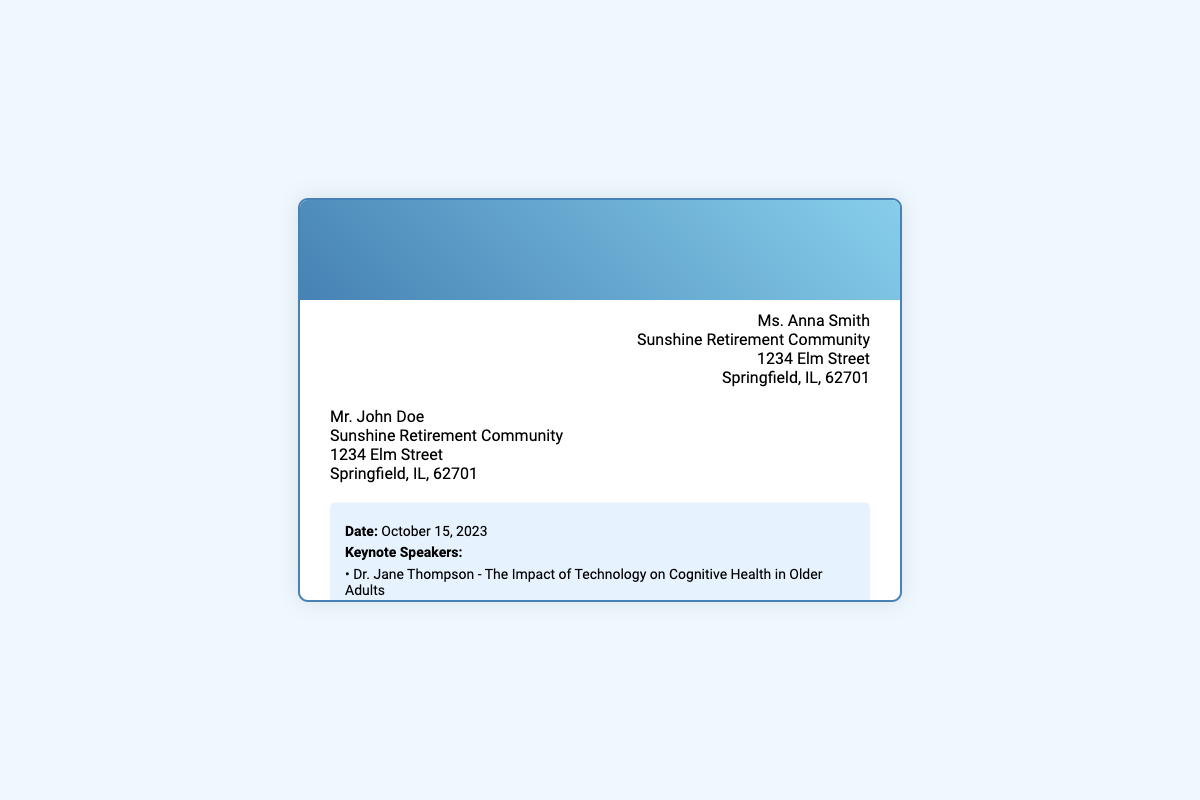What is the date of the Annual Technology Fair? The date is explicitly mentioned in the event details section of the document.
Answer: October 15, 2023 Who is one of the keynote speakers? The keynote speakers are listed in the event details, so we can reference that section for specific names.
Answer: Dr. Jane Thompson What is the title of Dr. Jane Thompson's keynote address? The title of the keynote address is provided alongside the speaker's name in the details provided.
Answer: The Impact of Technology on Cognitive Health in Older Adults How many keynote speakers are mentioned? The document lists the keynote speakers, providing a clear answer to the count.
Answer: Two What type of exhibits will be available? The types of exhibits are given in the event details, making it easy to identify them.
Answer: Virtual Reality Experiences Who should attendees contact for RSVP? The contact for RSVP is specified towards the end of the envelope content, providing a direct answer.
Answer: Ms. Linda Carter What is the contact number for the event coordinator? The contact number is explicitly provided in the RSVP section of the document.
Answer: (217) 555-6789 Who is the sender of the invitation? The sender's details are mentioned at the top of the document, allowing for a straightforward identification.
Answer: Ms. Anna Smith What is the theme of Mr. Paul Hamilton's keynote address? The theme is explained in a brief description following the speaker's name in the document.
Answer: Bridging the Digital Divide: Tools and Resources for Senior Citizens 